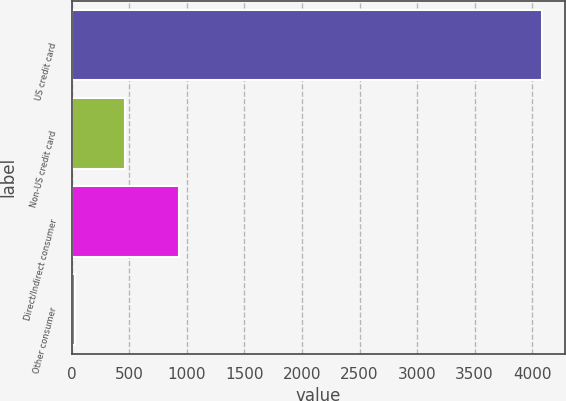Convert chart to OTSL. <chart><loc_0><loc_0><loc_500><loc_500><bar_chart><fcel>US credit card<fcel>Non-US credit card<fcel>Direct/Indirect consumer<fcel>Other consumer<nl><fcel>4085<fcel>464<fcel>929<fcel>29<nl></chart> 